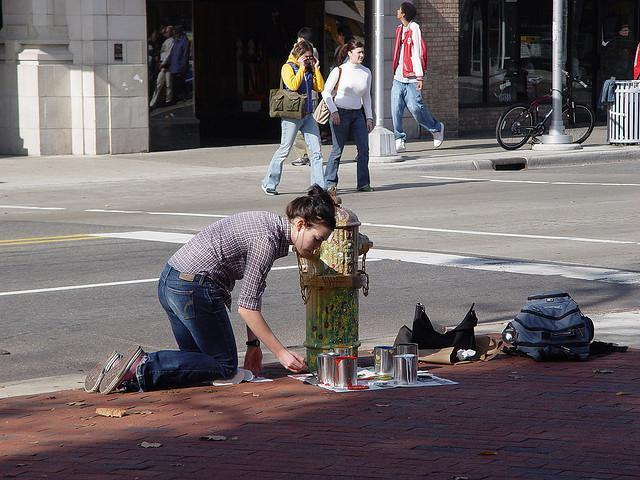How many people can be seen?
Give a very brief answer. 4. 